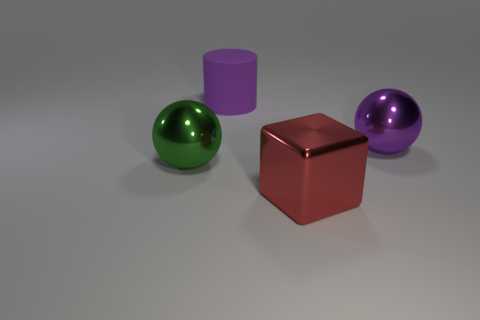What might be the purpose of this arrangement of objects? This arrangement of objects could serve illustrative purposes, such as in a 3D modeling or rendering tutorial. Each object's material and shape can show how light and shadows interact with different geometries, potentially serving as a visual guide for students or designers. How would the scene change if the cube were glass? If the cube were made of glass, it would be more transparent and reflective, which would drastically change the visual dynamics of the scene. The cube would reflect and refract the surrounding objects and light, adding complexity to the composition with additional highlights, shadows, and potential distortion of the objects behind it. 